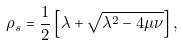Convert formula to latex. <formula><loc_0><loc_0><loc_500><loc_500>\rho _ { s } = \frac { 1 } { 2 } \left [ \lambda + \sqrt { \lambda ^ { 2 } - 4 \mu \nu } \right ] ,</formula> 